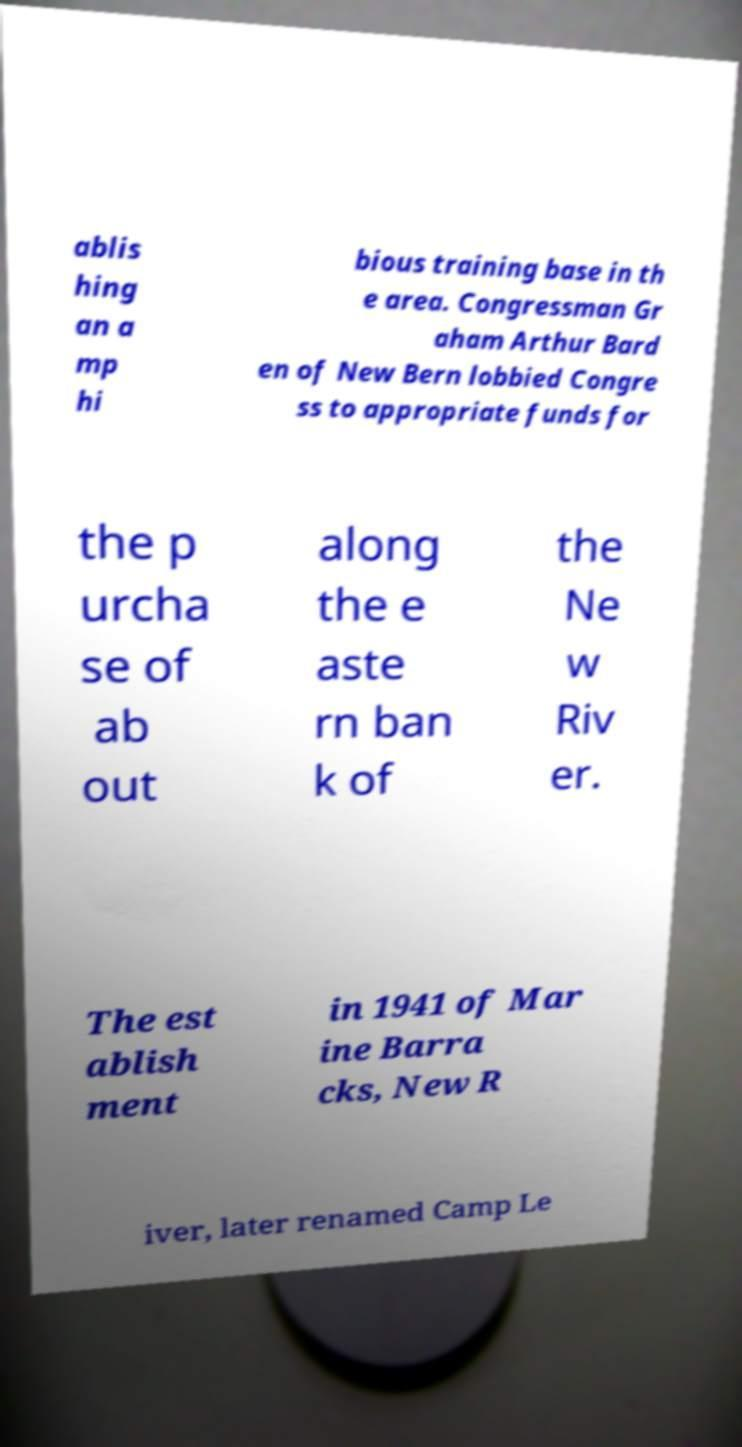Could you assist in decoding the text presented in this image and type it out clearly? ablis hing an a mp hi bious training base in th e area. Congressman Gr aham Arthur Bard en of New Bern lobbied Congre ss to appropriate funds for the p urcha se of ab out along the e aste rn ban k of the Ne w Riv er. The est ablish ment in 1941 of Mar ine Barra cks, New R iver, later renamed Camp Le 